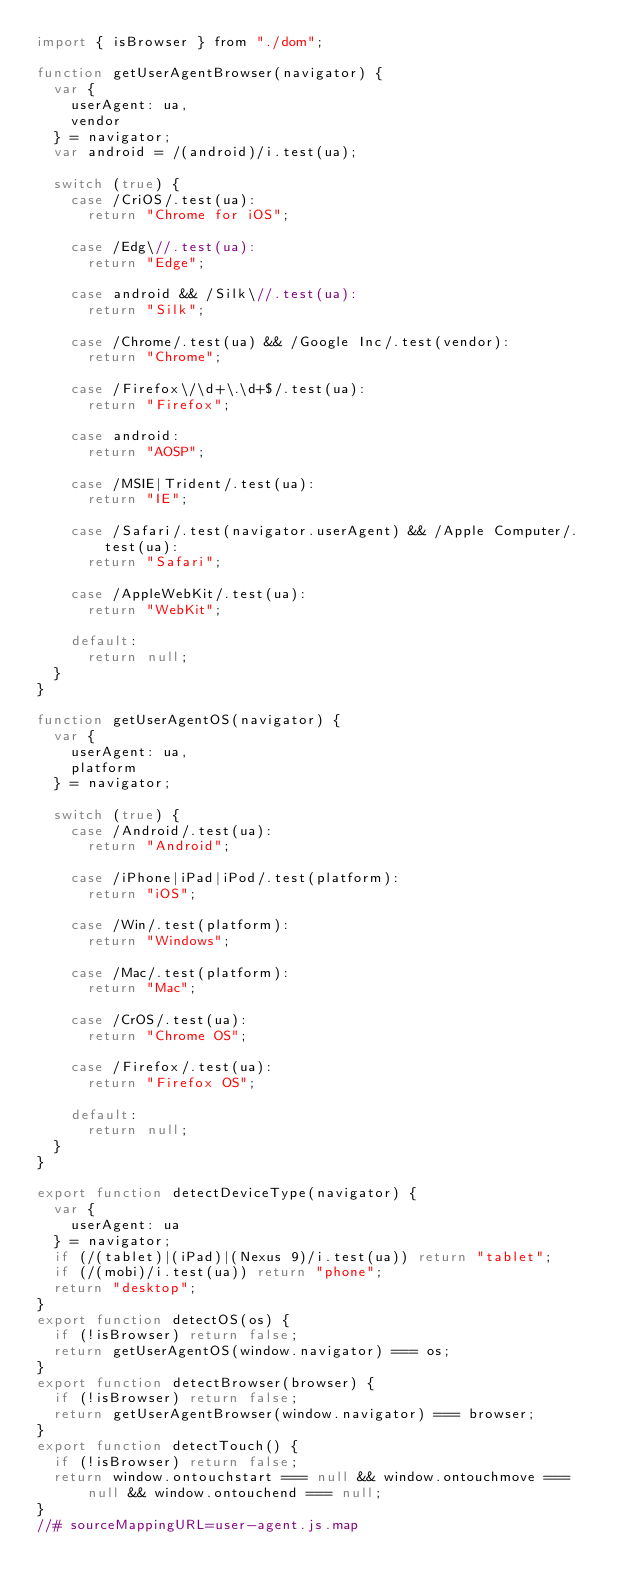Convert code to text. <code><loc_0><loc_0><loc_500><loc_500><_JavaScript_>import { isBrowser } from "./dom";

function getUserAgentBrowser(navigator) {
  var {
    userAgent: ua,
    vendor
  } = navigator;
  var android = /(android)/i.test(ua);

  switch (true) {
    case /CriOS/.test(ua):
      return "Chrome for iOS";

    case /Edg\//.test(ua):
      return "Edge";

    case android && /Silk\//.test(ua):
      return "Silk";

    case /Chrome/.test(ua) && /Google Inc/.test(vendor):
      return "Chrome";

    case /Firefox\/\d+\.\d+$/.test(ua):
      return "Firefox";

    case android:
      return "AOSP";

    case /MSIE|Trident/.test(ua):
      return "IE";

    case /Safari/.test(navigator.userAgent) && /Apple Computer/.test(ua):
      return "Safari";

    case /AppleWebKit/.test(ua):
      return "WebKit";

    default:
      return null;
  }
}

function getUserAgentOS(navigator) {
  var {
    userAgent: ua,
    platform
  } = navigator;

  switch (true) {
    case /Android/.test(ua):
      return "Android";

    case /iPhone|iPad|iPod/.test(platform):
      return "iOS";

    case /Win/.test(platform):
      return "Windows";

    case /Mac/.test(platform):
      return "Mac";

    case /CrOS/.test(ua):
      return "Chrome OS";

    case /Firefox/.test(ua):
      return "Firefox OS";

    default:
      return null;
  }
}

export function detectDeviceType(navigator) {
  var {
    userAgent: ua
  } = navigator;
  if (/(tablet)|(iPad)|(Nexus 9)/i.test(ua)) return "tablet";
  if (/(mobi)/i.test(ua)) return "phone";
  return "desktop";
}
export function detectOS(os) {
  if (!isBrowser) return false;
  return getUserAgentOS(window.navigator) === os;
}
export function detectBrowser(browser) {
  if (!isBrowser) return false;
  return getUserAgentBrowser(window.navigator) === browser;
}
export function detectTouch() {
  if (!isBrowser) return false;
  return window.ontouchstart === null && window.ontouchmove === null && window.ontouchend === null;
}
//# sourceMappingURL=user-agent.js.map</code> 